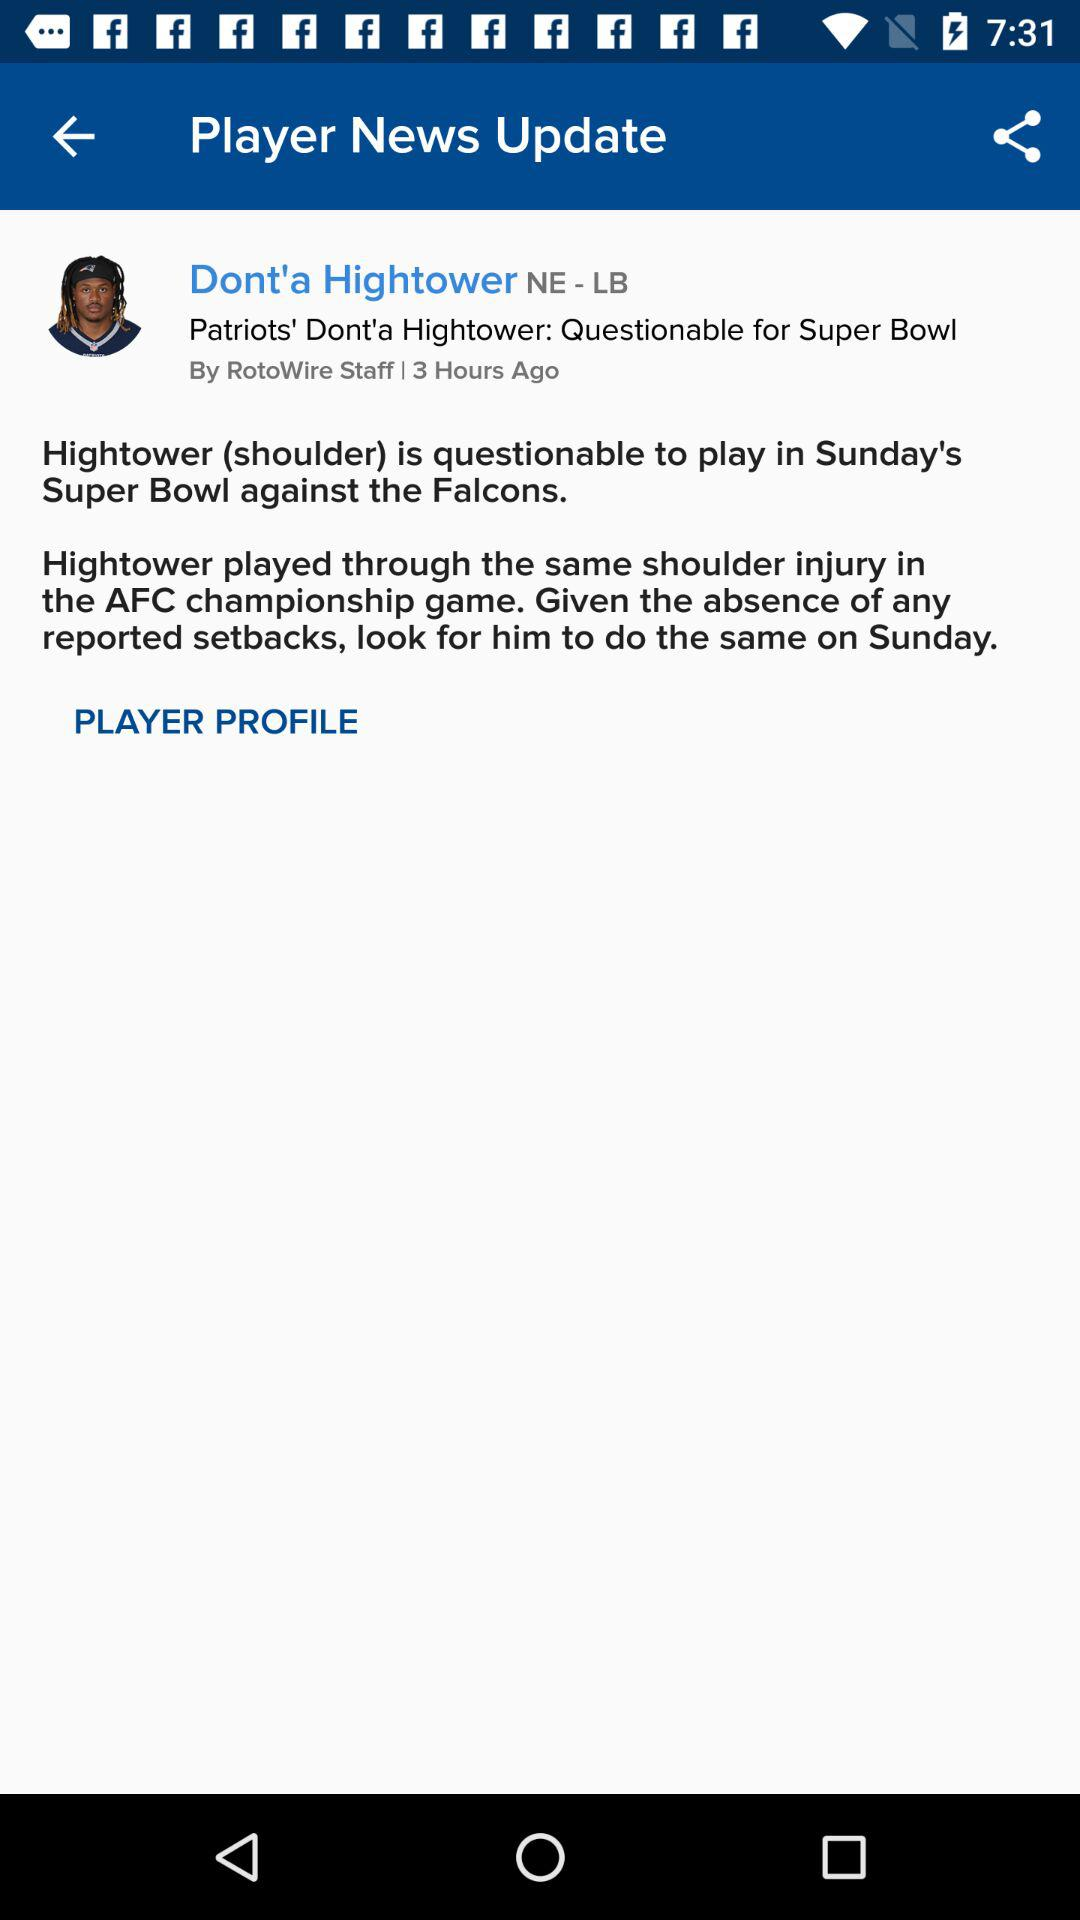Who posted this news? The news was posted by RotoWire Staff. 